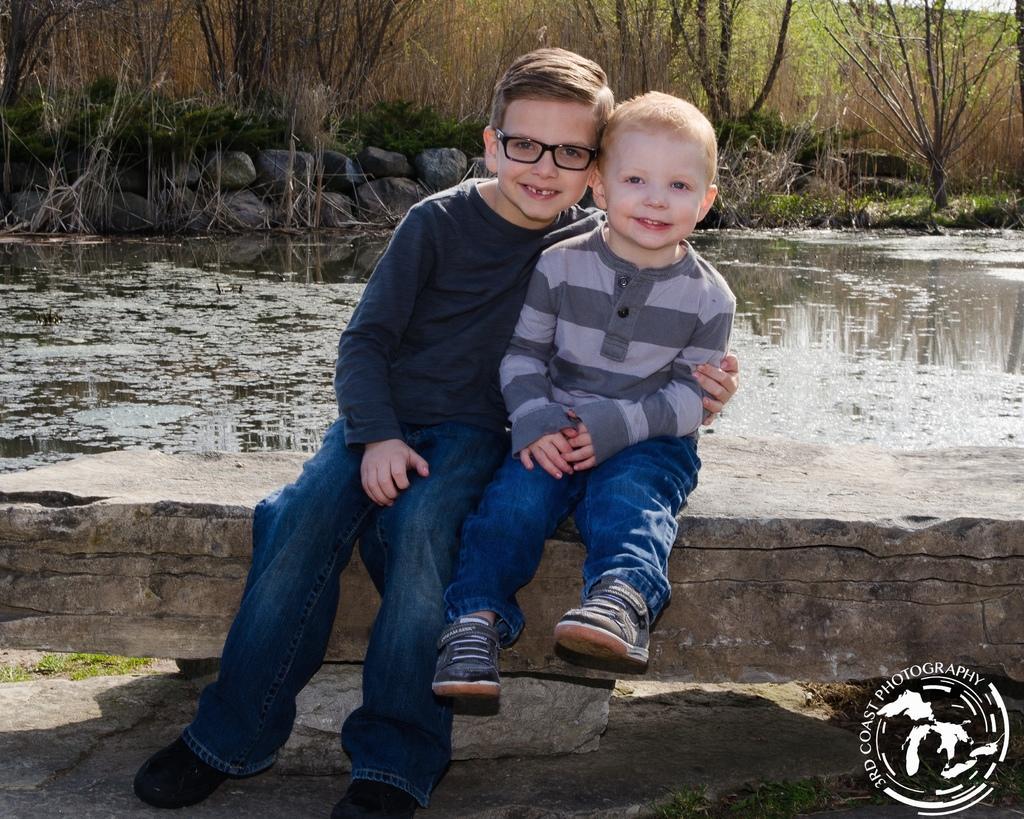Describe this image in one or two sentences. In this picture I can see two boys sitting and smiling, there is water, rocks, and in the background there are trees and there is a watermark on the image. 